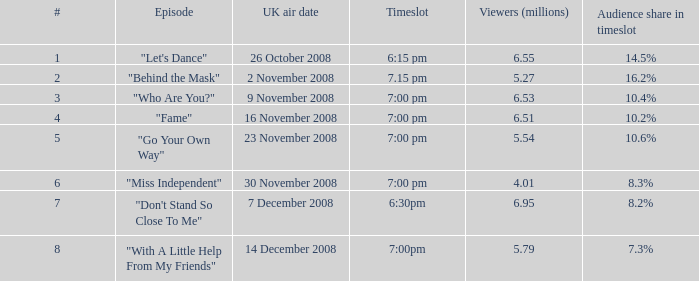Name the total number of viewers for audience share in timeslot for 10.2% 1.0. 